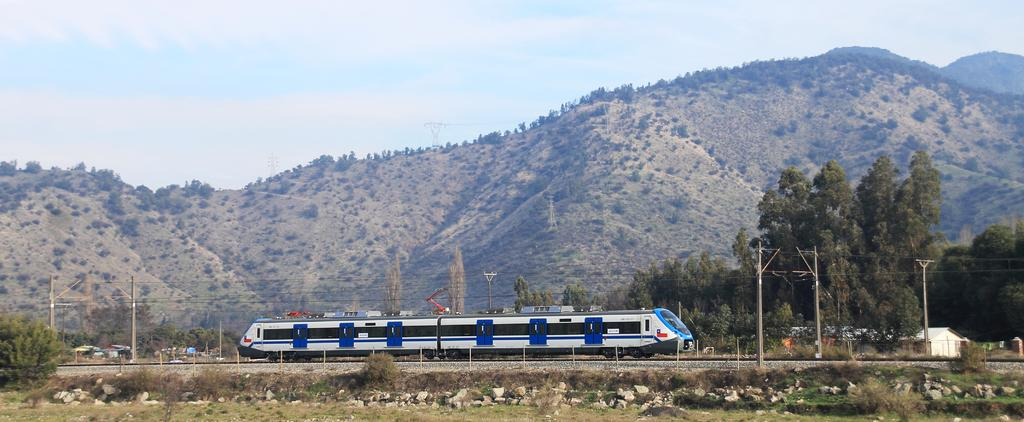What type of natural elements can be seen in the image? There are trees, rocks, plants, and hills visible in the image. What type of man-made structures are present in the image? There are houses and current poles in the image. What mode of transportation can be seen in the image? There is a train on a railway track in the image. What is visible in the background of the image? The sky is visible in the background of the image. What type of cow can be seen in the image? There is no cow present in the image. What is the caption of the image? The image does not have a caption, as it is a visual representation without accompanying text. 